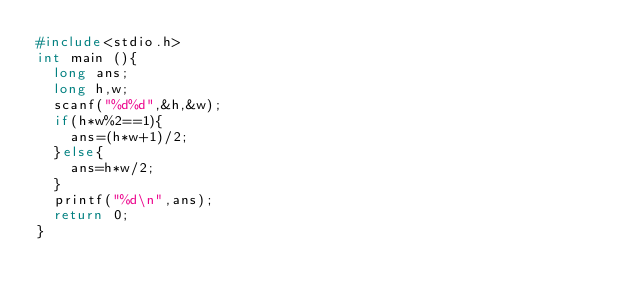<code> <loc_0><loc_0><loc_500><loc_500><_C_>#include<stdio.h>
int main (){
  long ans;
  long h,w;
  scanf("%d%d",&h,&w);
  if(h*w%2==1){
    ans=(h*w+1)/2;
  }else{
    ans=h*w/2;
  }
  printf("%d\n",ans);
  return 0;
}</code> 